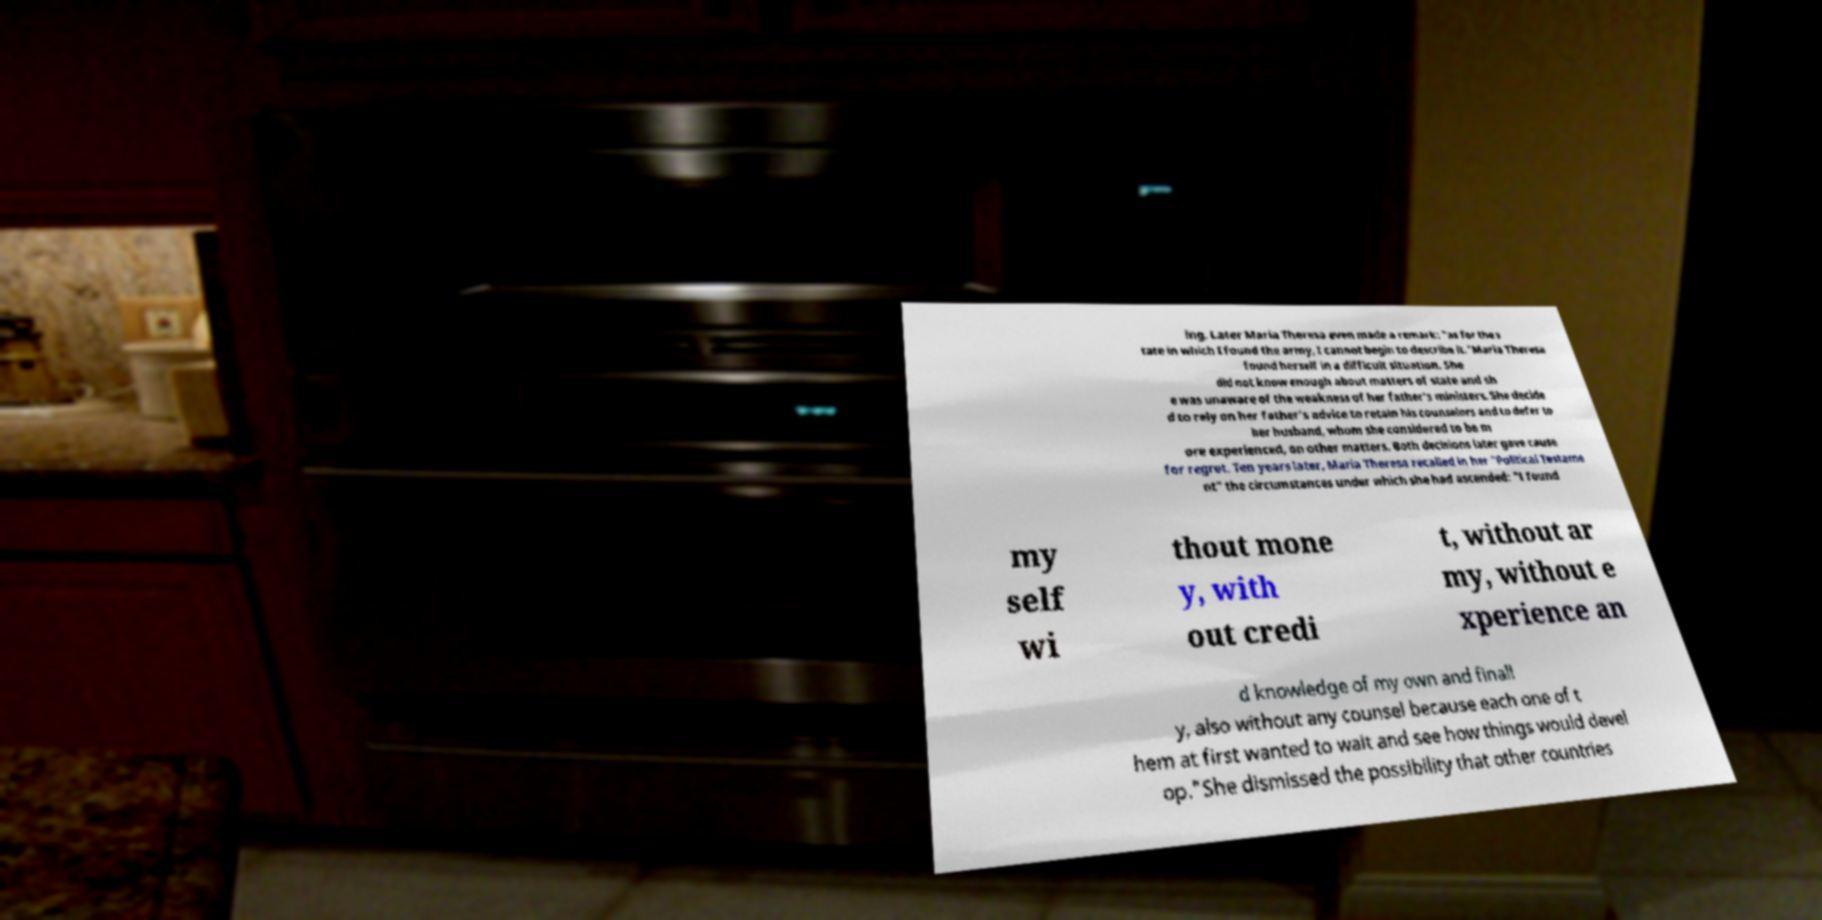For documentation purposes, I need the text within this image transcribed. Could you provide that? ing. Later Maria Theresa even made a remark: "as for the s tate in which I found the army, I cannot begin to describe it."Maria Theresa found herself in a difficult situation. She did not know enough about matters of state and sh e was unaware of the weakness of her father's ministers. She decide d to rely on her father's advice to retain his counselors and to defer to her husband, whom she considered to be m ore experienced, on other matters. Both decisions later gave cause for regret. Ten years later, Maria Theresa recalled in her "Political Testame nt" the circumstances under which she had ascended: "I found my self wi thout mone y, with out credi t, without ar my, without e xperience an d knowledge of my own and finall y, also without any counsel because each one of t hem at first wanted to wait and see how things would devel op."She dismissed the possibility that other countries 